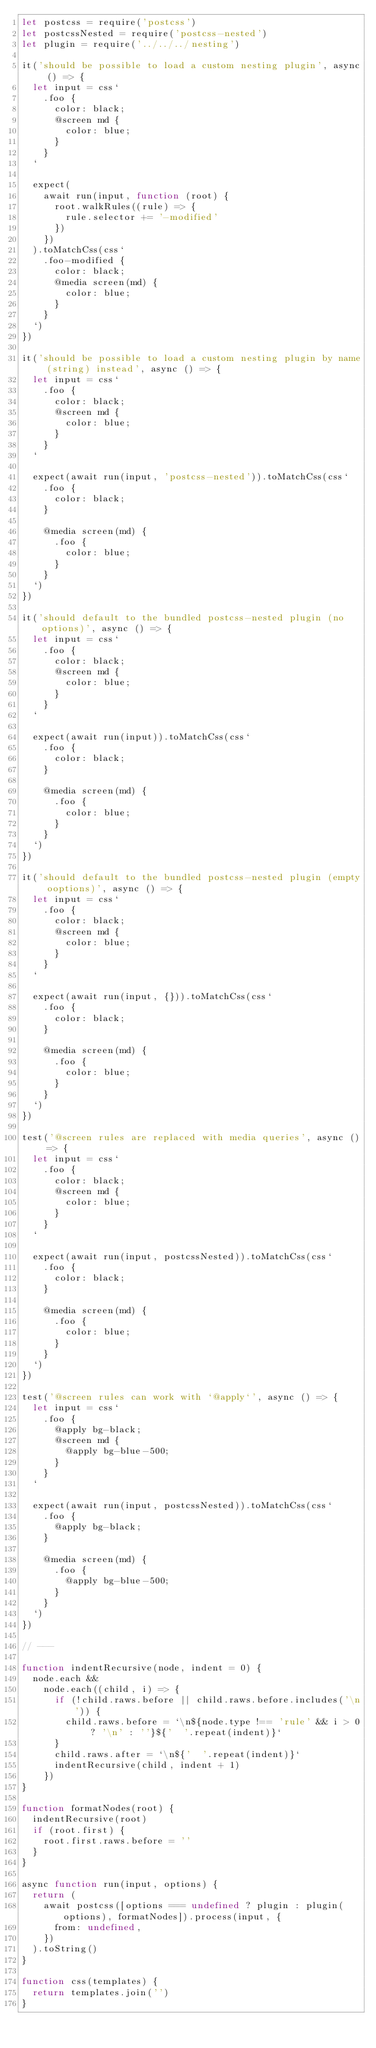Convert code to text. <code><loc_0><loc_0><loc_500><loc_500><_JavaScript_>let postcss = require('postcss')
let postcssNested = require('postcss-nested')
let plugin = require('../../../nesting')

it('should be possible to load a custom nesting plugin', async () => {
  let input = css`
    .foo {
      color: black;
      @screen md {
        color: blue;
      }
    }
  `

  expect(
    await run(input, function (root) {
      root.walkRules((rule) => {
        rule.selector += '-modified'
      })
    })
  ).toMatchCss(css`
    .foo-modified {
      color: black;
      @media screen(md) {
        color: blue;
      }
    }
  `)
})

it('should be possible to load a custom nesting plugin by name (string) instead', async () => {
  let input = css`
    .foo {
      color: black;
      @screen md {
        color: blue;
      }
    }
  `

  expect(await run(input, 'postcss-nested')).toMatchCss(css`
    .foo {
      color: black;
    }

    @media screen(md) {
      .foo {
        color: blue;
      }
    }
  `)
})

it('should default to the bundled postcss-nested plugin (no options)', async () => {
  let input = css`
    .foo {
      color: black;
      @screen md {
        color: blue;
      }
    }
  `

  expect(await run(input)).toMatchCss(css`
    .foo {
      color: black;
    }

    @media screen(md) {
      .foo {
        color: blue;
      }
    }
  `)
})

it('should default to the bundled postcss-nested plugin (empty ooptions)', async () => {
  let input = css`
    .foo {
      color: black;
      @screen md {
        color: blue;
      }
    }
  `

  expect(await run(input, {})).toMatchCss(css`
    .foo {
      color: black;
    }

    @media screen(md) {
      .foo {
        color: blue;
      }
    }
  `)
})

test('@screen rules are replaced with media queries', async () => {
  let input = css`
    .foo {
      color: black;
      @screen md {
        color: blue;
      }
    }
  `

  expect(await run(input, postcssNested)).toMatchCss(css`
    .foo {
      color: black;
    }

    @media screen(md) {
      .foo {
        color: blue;
      }
    }
  `)
})

test('@screen rules can work with `@apply`', async () => {
  let input = css`
    .foo {
      @apply bg-black;
      @screen md {
        @apply bg-blue-500;
      }
    }
  `

  expect(await run(input, postcssNested)).toMatchCss(css`
    .foo {
      @apply bg-black;
    }

    @media screen(md) {
      .foo {
        @apply bg-blue-500;
      }
    }
  `)
})

// ---

function indentRecursive(node, indent = 0) {
  node.each &&
    node.each((child, i) => {
      if (!child.raws.before || child.raws.before.includes('\n')) {
        child.raws.before = `\n${node.type !== 'rule' && i > 0 ? '\n' : ''}${'  '.repeat(indent)}`
      }
      child.raws.after = `\n${'  '.repeat(indent)}`
      indentRecursive(child, indent + 1)
    })
}

function formatNodes(root) {
  indentRecursive(root)
  if (root.first) {
    root.first.raws.before = ''
  }
}

async function run(input, options) {
  return (
    await postcss([options === undefined ? plugin : plugin(options), formatNodes]).process(input, {
      from: undefined,
    })
  ).toString()
}

function css(templates) {
  return templates.join('')
}
</code> 